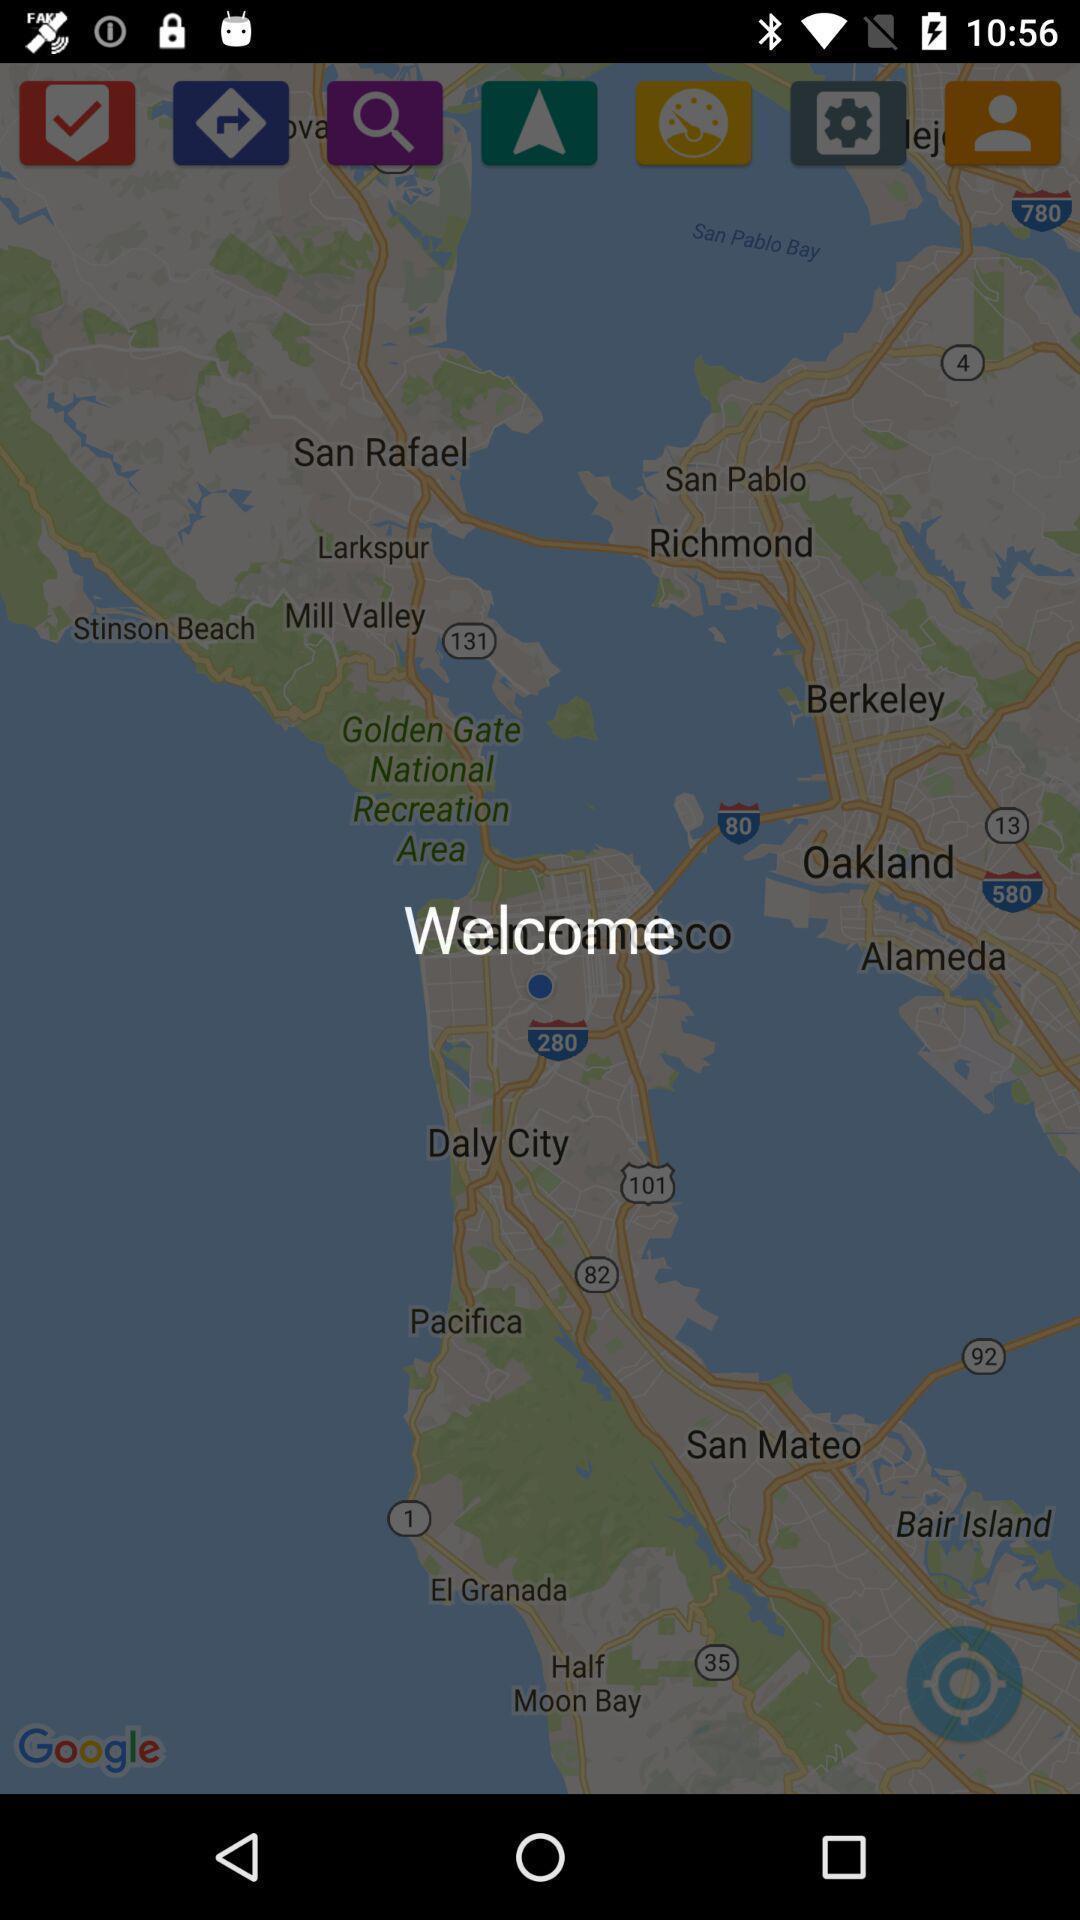Explain the elements present in this screenshot. Welcome page of an navigation application. 